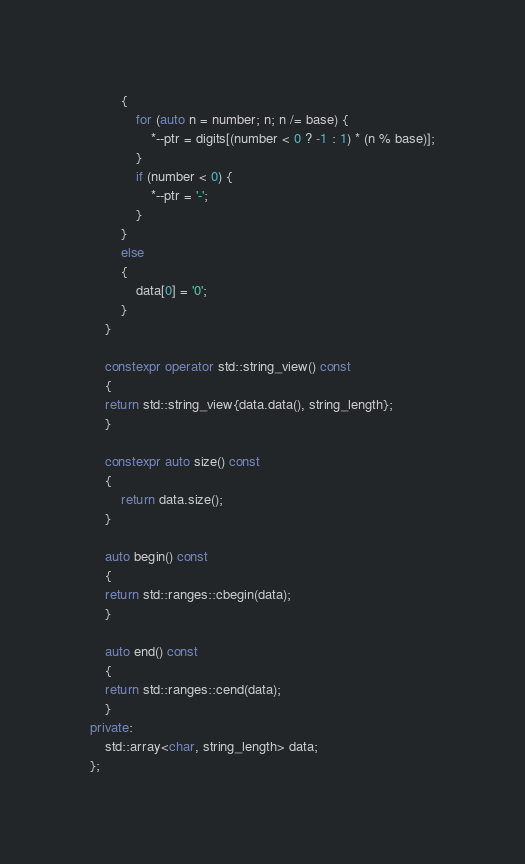Convert code to text. <code><loc_0><loc_0><loc_500><loc_500><_C++_>        {
            for (auto n = number; n; n /= base) {
                *--ptr = digits[(number < 0 ? -1 : 1) * (n % base)];
            }
            if (number < 0) {
                *--ptr = '-';
            }
        }
        else
        {
            data[0] = '0';
        }
    }

    constexpr operator std::string_view() const
    {
    return std::string_view{data.data(), string_length};
    }

    constexpr auto size() const
    {
        return data.size();
    }

    auto begin() const
    {
    return std::ranges::cbegin(data);
    }

    auto end() const
    {
    return std::ranges::cend(data);
    }
private:
    std::array<char, string_length> data;
};
</code> 